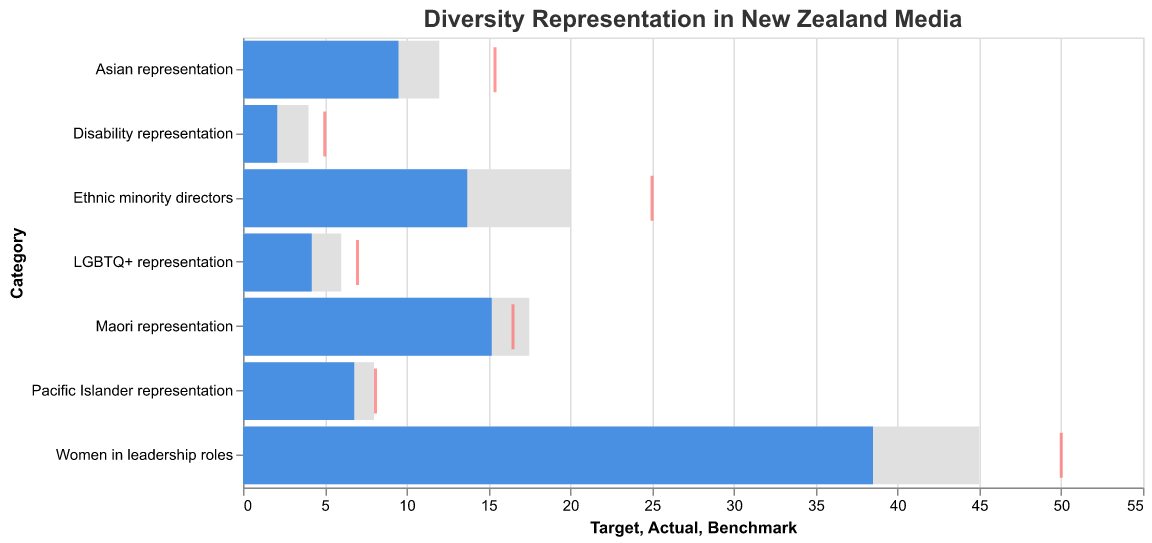What is the title of the figure? The title of the figure is displayed at the top. It provides a summary of what the chart is about. The title is "Diversity Representation in New Zealand Media".
Answer: Diversity Representation in New Zealand Media Which category has the highest target value? The heights of the bars for the target values show various amounts. By comparing these, we can see that the highest target value is for "Women in leadership roles" with a target of 45.0.
Answer: Women in leadership roles How far is Asian representation from reaching its target? Asian representation has an actual value of 9.5 and a target value of 12.0. Subtracting the actual value from the target gives us the difference: 12.0 - 9.5 = 2.5.
Answer: 2.5 What proportion of the target percentage has been reached for Disability representation? The proportion reached can be calculated by dividing the actual value by the target value and converting to a percentage:
(2.1 / 4.0) * 100 = 52.5%.
Answer: 52.5% Is the actual representation of Maori above, below, or equal to the industry benchmark? By comparing the actual value (15.2) with the benchmark (16.5), we can see that the actual representation is below the benchmark.
Answer: Below What is the difference between the target and benchmark values for Pacific Islander representation? The target value for Pacific Islander representation is 8.0, and the benchmark is 8.1. The difference is 8.1 - 8.0 = 0.1.
Answer: 0.1 How many categories have a higher actual value than target value? Comparing the actual values and target values for all categories, none of them have an actual value higher than the target value. This means zero categories meet this condition.
Answer: 0 